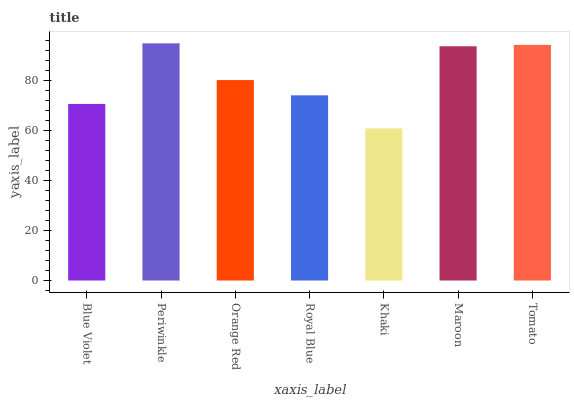Is Orange Red the minimum?
Answer yes or no. No. Is Orange Red the maximum?
Answer yes or no. No. Is Periwinkle greater than Orange Red?
Answer yes or no. Yes. Is Orange Red less than Periwinkle?
Answer yes or no. Yes. Is Orange Red greater than Periwinkle?
Answer yes or no. No. Is Periwinkle less than Orange Red?
Answer yes or no. No. Is Orange Red the high median?
Answer yes or no. Yes. Is Orange Red the low median?
Answer yes or no. Yes. Is Periwinkle the high median?
Answer yes or no. No. Is Maroon the low median?
Answer yes or no. No. 